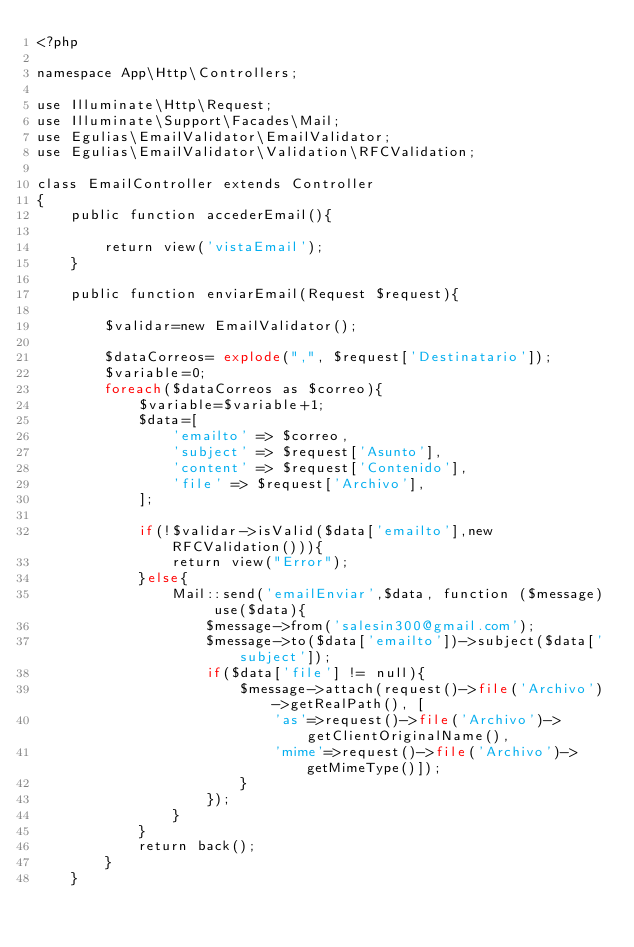Convert code to text. <code><loc_0><loc_0><loc_500><loc_500><_PHP_><?php

namespace App\Http\Controllers;

use Illuminate\Http\Request;
use Illuminate\Support\Facades\Mail;
use Egulias\EmailValidator\EmailValidator;
use Egulias\EmailValidator\Validation\RFCValidation;

class EmailController extends Controller
{
    public function accederEmail(){

        return view('vistaEmail');
    }

    public function enviarEmail(Request $request){

        $validar=new EmailValidator();

        $dataCorreos= explode(",", $request['Destinatario']);
        $variable=0;
        foreach($dataCorreos as $correo){
            $variable=$variable+1;
            $data=[
                'emailto' => $correo,
                'subject' => $request['Asunto'],
                'content' => $request['Contenido'],
                'file' => $request['Archivo'],
            ];
            
            if(!$validar->isValid($data['emailto'],new RFCValidation())){
                return view("Error");
            }else{
                Mail::send('emailEnviar',$data, function ($message) use($data){
                    $message->from('salesin300@gmail.com');
                    $message->to($data['emailto'])->subject($data['subject']);
                    if($data['file'] != null){
                        $message->attach(request()->file('Archivo')->getRealPath(), [
                            'as'=>request()->file('Archivo')->getClientOriginalName(),
                            'mime'=>request()->file('Archivo')->getMimeType()]);
                        }
                    });
                }
            }
            return back();
        }
    }</code> 